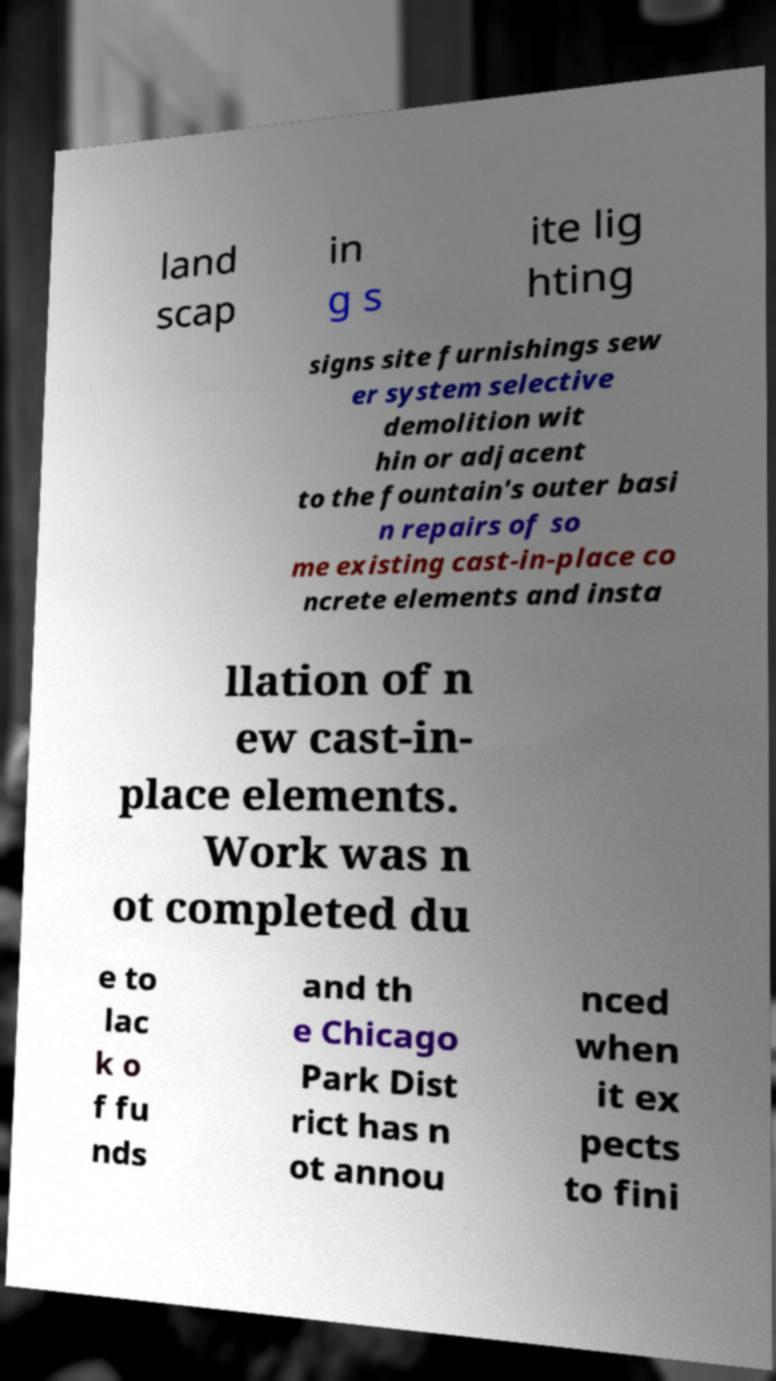Can you read and provide the text displayed in the image?This photo seems to have some interesting text. Can you extract and type it out for me? land scap in g s ite lig hting signs site furnishings sew er system selective demolition wit hin or adjacent to the fountain's outer basi n repairs of so me existing cast-in-place co ncrete elements and insta llation of n ew cast-in- place elements. Work was n ot completed du e to lac k o f fu nds and th e Chicago Park Dist rict has n ot annou nced when it ex pects to fini 